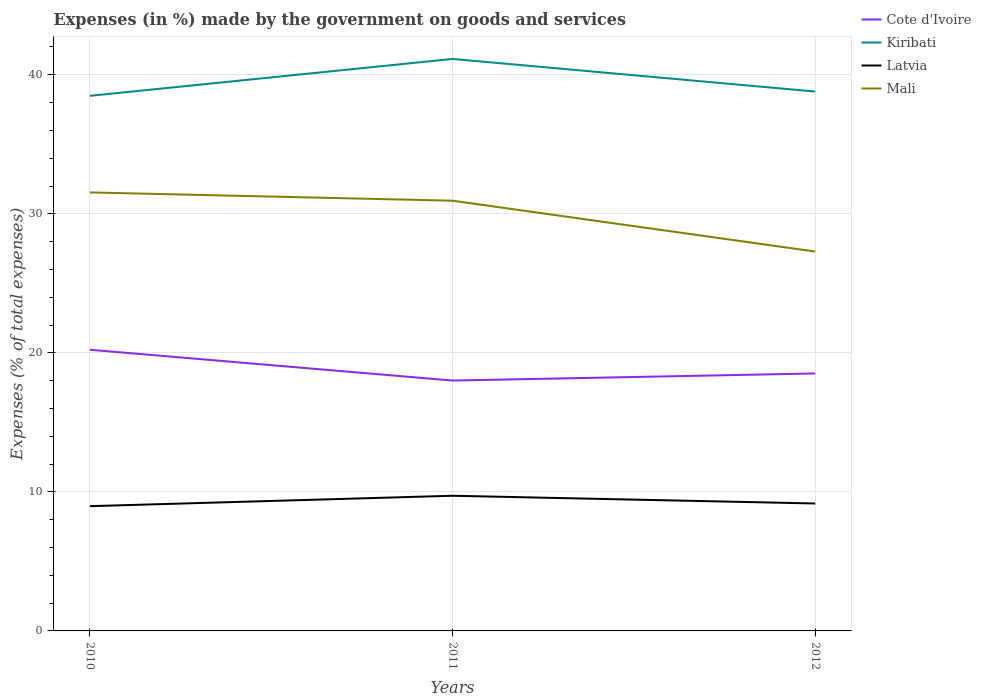How many different coloured lines are there?
Offer a terse response. 4. Across all years, what is the maximum percentage of expenses made by the government on goods and services in Kiribati?
Provide a short and direct response. 38.49. What is the total percentage of expenses made by the government on goods and services in Mali in the graph?
Provide a succinct answer. 4.25. What is the difference between the highest and the second highest percentage of expenses made by the government on goods and services in Kiribati?
Offer a very short reply. 2.65. What is the difference between the highest and the lowest percentage of expenses made by the government on goods and services in Mali?
Keep it short and to the point. 2. Is the percentage of expenses made by the government on goods and services in Latvia strictly greater than the percentage of expenses made by the government on goods and services in Mali over the years?
Your answer should be very brief. Yes. How many lines are there?
Provide a succinct answer. 4. How many years are there in the graph?
Your response must be concise. 3. Are the values on the major ticks of Y-axis written in scientific E-notation?
Provide a succinct answer. No. Does the graph contain any zero values?
Your answer should be compact. No. Does the graph contain grids?
Your answer should be very brief. Yes. How many legend labels are there?
Your answer should be compact. 4. What is the title of the graph?
Keep it short and to the point. Expenses (in %) made by the government on goods and services. What is the label or title of the Y-axis?
Offer a terse response. Expenses (% of total expenses). What is the Expenses (% of total expenses) of Cote d'Ivoire in 2010?
Offer a terse response. 20.22. What is the Expenses (% of total expenses) in Kiribati in 2010?
Your response must be concise. 38.49. What is the Expenses (% of total expenses) in Latvia in 2010?
Provide a succinct answer. 8.97. What is the Expenses (% of total expenses) in Mali in 2010?
Offer a very short reply. 31.54. What is the Expenses (% of total expenses) of Cote d'Ivoire in 2011?
Offer a terse response. 18.01. What is the Expenses (% of total expenses) in Kiribati in 2011?
Ensure brevity in your answer.  41.14. What is the Expenses (% of total expenses) in Latvia in 2011?
Provide a short and direct response. 9.72. What is the Expenses (% of total expenses) of Mali in 2011?
Give a very brief answer. 30.94. What is the Expenses (% of total expenses) in Cote d'Ivoire in 2012?
Keep it short and to the point. 18.52. What is the Expenses (% of total expenses) of Kiribati in 2012?
Your answer should be compact. 38.79. What is the Expenses (% of total expenses) in Latvia in 2012?
Provide a short and direct response. 9.17. What is the Expenses (% of total expenses) in Mali in 2012?
Offer a very short reply. 27.29. Across all years, what is the maximum Expenses (% of total expenses) of Cote d'Ivoire?
Offer a terse response. 20.22. Across all years, what is the maximum Expenses (% of total expenses) in Kiribati?
Your answer should be very brief. 41.14. Across all years, what is the maximum Expenses (% of total expenses) in Latvia?
Provide a succinct answer. 9.72. Across all years, what is the maximum Expenses (% of total expenses) in Mali?
Make the answer very short. 31.54. Across all years, what is the minimum Expenses (% of total expenses) in Cote d'Ivoire?
Offer a very short reply. 18.01. Across all years, what is the minimum Expenses (% of total expenses) of Kiribati?
Your answer should be very brief. 38.49. Across all years, what is the minimum Expenses (% of total expenses) of Latvia?
Provide a succinct answer. 8.97. Across all years, what is the minimum Expenses (% of total expenses) of Mali?
Provide a succinct answer. 27.29. What is the total Expenses (% of total expenses) in Cote d'Ivoire in the graph?
Make the answer very short. 56.75. What is the total Expenses (% of total expenses) of Kiribati in the graph?
Your answer should be compact. 118.42. What is the total Expenses (% of total expenses) of Latvia in the graph?
Your response must be concise. 27.86. What is the total Expenses (% of total expenses) in Mali in the graph?
Offer a terse response. 89.77. What is the difference between the Expenses (% of total expenses) in Cote d'Ivoire in 2010 and that in 2011?
Make the answer very short. 2.22. What is the difference between the Expenses (% of total expenses) of Kiribati in 2010 and that in 2011?
Make the answer very short. -2.65. What is the difference between the Expenses (% of total expenses) of Latvia in 2010 and that in 2011?
Ensure brevity in your answer.  -0.75. What is the difference between the Expenses (% of total expenses) in Mali in 2010 and that in 2011?
Provide a short and direct response. 0.6. What is the difference between the Expenses (% of total expenses) of Cote d'Ivoire in 2010 and that in 2012?
Make the answer very short. 1.71. What is the difference between the Expenses (% of total expenses) of Kiribati in 2010 and that in 2012?
Your answer should be very brief. -0.31. What is the difference between the Expenses (% of total expenses) of Latvia in 2010 and that in 2012?
Keep it short and to the point. -0.19. What is the difference between the Expenses (% of total expenses) of Mali in 2010 and that in 2012?
Ensure brevity in your answer.  4.25. What is the difference between the Expenses (% of total expenses) in Cote d'Ivoire in 2011 and that in 2012?
Give a very brief answer. -0.51. What is the difference between the Expenses (% of total expenses) of Kiribati in 2011 and that in 2012?
Give a very brief answer. 2.35. What is the difference between the Expenses (% of total expenses) in Latvia in 2011 and that in 2012?
Ensure brevity in your answer.  0.56. What is the difference between the Expenses (% of total expenses) of Mali in 2011 and that in 2012?
Give a very brief answer. 3.66. What is the difference between the Expenses (% of total expenses) of Cote d'Ivoire in 2010 and the Expenses (% of total expenses) of Kiribati in 2011?
Provide a succinct answer. -20.92. What is the difference between the Expenses (% of total expenses) of Cote d'Ivoire in 2010 and the Expenses (% of total expenses) of Latvia in 2011?
Ensure brevity in your answer.  10.5. What is the difference between the Expenses (% of total expenses) in Cote d'Ivoire in 2010 and the Expenses (% of total expenses) in Mali in 2011?
Provide a succinct answer. -10.72. What is the difference between the Expenses (% of total expenses) in Kiribati in 2010 and the Expenses (% of total expenses) in Latvia in 2011?
Your answer should be very brief. 28.76. What is the difference between the Expenses (% of total expenses) in Kiribati in 2010 and the Expenses (% of total expenses) in Mali in 2011?
Provide a short and direct response. 7.54. What is the difference between the Expenses (% of total expenses) of Latvia in 2010 and the Expenses (% of total expenses) of Mali in 2011?
Your response must be concise. -21.97. What is the difference between the Expenses (% of total expenses) in Cote d'Ivoire in 2010 and the Expenses (% of total expenses) in Kiribati in 2012?
Your answer should be compact. -18.57. What is the difference between the Expenses (% of total expenses) in Cote d'Ivoire in 2010 and the Expenses (% of total expenses) in Latvia in 2012?
Your answer should be very brief. 11.06. What is the difference between the Expenses (% of total expenses) in Cote d'Ivoire in 2010 and the Expenses (% of total expenses) in Mali in 2012?
Provide a short and direct response. -7.06. What is the difference between the Expenses (% of total expenses) in Kiribati in 2010 and the Expenses (% of total expenses) in Latvia in 2012?
Your answer should be very brief. 29.32. What is the difference between the Expenses (% of total expenses) of Kiribati in 2010 and the Expenses (% of total expenses) of Mali in 2012?
Offer a terse response. 11.2. What is the difference between the Expenses (% of total expenses) of Latvia in 2010 and the Expenses (% of total expenses) of Mali in 2012?
Offer a very short reply. -18.31. What is the difference between the Expenses (% of total expenses) of Cote d'Ivoire in 2011 and the Expenses (% of total expenses) of Kiribati in 2012?
Provide a short and direct response. -20.79. What is the difference between the Expenses (% of total expenses) of Cote d'Ivoire in 2011 and the Expenses (% of total expenses) of Latvia in 2012?
Provide a succinct answer. 8.84. What is the difference between the Expenses (% of total expenses) of Cote d'Ivoire in 2011 and the Expenses (% of total expenses) of Mali in 2012?
Keep it short and to the point. -9.28. What is the difference between the Expenses (% of total expenses) in Kiribati in 2011 and the Expenses (% of total expenses) in Latvia in 2012?
Keep it short and to the point. 31.97. What is the difference between the Expenses (% of total expenses) of Kiribati in 2011 and the Expenses (% of total expenses) of Mali in 2012?
Your answer should be very brief. 13.85. What is the difference between the Expenses (% of total expenses) of Latvia in 2011 and the Expenses (% of total expenses) of Mali in 2012?
Your answer should be compact. -17.56. What is the average Expenses (% of total expenses) in Cote d'Ivoire per year?
Your answer should be very brief. 18.92. What is the average Expenses (% of total expenses) of Kiribati per year?
Provide a short and direct response. 39.47. What is the average Expenses (% of total expenses) of Latvia per year?
Give a very brief answer. 9.29. What is the average Expenses (% of total expenses) in Mali per year?
Your response must be concise. 29.92. In the year 2010, what is the difference between the Expenses (% of total expenses) of Cote d'Ivoire and Expenses (% of total expenses) of Kiribati?
Keep it short and to the point. -18.26. In the year 2010, what is the difference between the Expenses (% of total expenses) of Cote d'Ivoire and Expenses (% of total expenses) of Latvia?
Keep it short and to the point. 11.25. In the year 2010, what is the difference between the Expenses (% of total expenses) in Cote d'Ivoire and Expenses (% of total expenses) in Mali?
Ensure brevity in your answer.  -11.32. In the year 2010, what is the difference between the Expenses (% of total expenses) in Kiribati and Expenses (% of total expenses) in Latvia?
Your answer should be very brief. 29.51. In the year 2010, what is the difference between the Expenses (% of total expenses) in Kiribati and Expenses (% of total expenses) in Mali?
Offer a terse response. 6.95. In the year 2010, what is the difference between the Expenses (% of total expenses) of Latvia and Expenses (% of total expenses) of Mali?
Make the answer very short. -22.57. In the year 2011, what is the difference between the Expenses (% of total expenses) in Cote d'Ivoire and Expenses (% of total expenses) in Kiribati?
Keep it short and to the point. -23.13. In the year 2011, what is the difference between the Expenses (% of total expenses) of Cote d'Ivoire and Expenses (% of total expenses) of Latvia?
Offer a terse response. 8.29. In the year 2011, what is the difference between the Expenses (% of total expenses) in Cote d'Ivoire and Expenses (% of total expenses) in Mali?
Provide a short and direct response. -12.94. In the year 2011, what is the difference between the Expenses (% of total expenses) of Kiribati and Expenses (% of total expenses) of Latvia?
Make the answer very short. 31.42. In the year 2011, what is the difference between the Expenses (% of total expenses) of Kiribati and Expenses (% of total expenses) of Mali?
Make the answer very short. 10.2. In the year 2011, what is the difference between the Expenses (% of total expenses) in Latvia and Expenses (% of total expenses) in Mali?
Keep it short and to the point. -21.22. In the year 2012, what is the difference between the Expenses (% of total expenses) in Cote d'Ivoire and Expenses (% of total expenses) in Kiribati?
Your response must be concise. -20.28. In the year 2012, what is the difference between the Expenses (% of total expenses) in Cote d'Ivoire and Expenses (% of total expenses) in Latvia?
Provide a succinct answer. 9.35. In the year 2012, what is the difference between the Expenses (% of total expenses) in Cote d'Ivoire and Expenses (% of total expenses) in Mali?
Keep it short and to the point. -8.77. In the year 2012, what is the difference between the Expenses (% of total expenses) of Kiribati and Expenses (% of total expenses) of Latvia?
Ensure brevity in your answer.  29.63. In the year 2012, what is the difference between the Expenses (% of total expenses) in Kiribati and Expenses (% of total expenses) in Mali?
Your answer should be compact. 11.51. In the year 2012, what is the difference between the Expenses (% of total expenses) of Latvia and Expenses (% of total expenses) of Mali?
Provide a short and direct response. -18.12. What is the ratio of the Expenses (% of total expenses) of Cote d'Ivoire in 2010 to that in 2011?
Provide a short and direct response. 1.12. What is the ratio of the Expenses (% of total expenses) in Kiribati in 2010 to that in 2011?
Your response must be concise. 0.94. What is the ratio of the Expenses (% of total expenses) of Latvia in 2010 to that in 2011?
Your answer should be very brief. 0.92. What is the ratio of the Expenses (% of total expenses) in Mali in 2010 to that in 2011?
Your answer should be compact. 1.02. What is the ratio of the Expenses (% of total expenses) in Cote d'Ivoire in 2010 to that in 2012?
Ensure brevity in your answer.  1.09. What is the ratio of the Expenses (% of total expenses) in Latvia in 2010 to that in 2012?
Provide a succinct answer. 0.98. What is the ratio of the Expenses (% of total expenses) of Mali in 2010 to that in 2012?
Keep it short and to the point. 1.16. What is the ratio of the Expenses (% of total expenses) of Cote d'Ivoire in 2011 to that in 2012?
Ensure brevity in your answer.  0.97. What is the ratio of the Expenses (% of total expenses) of Kiribati in 2011 to that in 2012?
Your answer should be compact. 1.06. What is the ratio of the Expenses (% of total expenses) in Latvia in 2011 to that in 2012?
Keep it short and to the point. 1.06. What is the ratio of the Expenses (% of total expenses) in Mali in 2011 to that in 2012?
Keep it short and to the point. 1.13. What is the difference between the highest and the second highest Expenses (% of total expenses) in Cote d'Ivoire?
Give a very brief answer. 1.71. What is the difference between the highest and the second highest Expenses (% of total expenses) of Kiribati?
Your answer should be very brief. 2.35. What is the difference between the highest and the second highest Expenses (% of total expenses) in Latvia?
Ensure brevity in your answer.  0.56. What is the difference between the highest and the second highest Expenses (% of total expenses) in Mali?
Offer a terse response. 0.6. What is the difference between the highest and the lowest Expenses (% of total expenses) of Cote d'Ivoire?
Make the answer very short. 2.22. What is the difference between the highest and the lowest Expenses (% of total expenses) in Kiribati?
Offer a very short reply. 2.65. What is the difference between the highest and the lowest Expenses (% of total expenses) of Latvia?
Provide a succinct answer. 0.75. What is the difference between the highest and the lowest Expenses (% of total expenses) of Mali?
Ensure brevity in your answer.  4.25. 